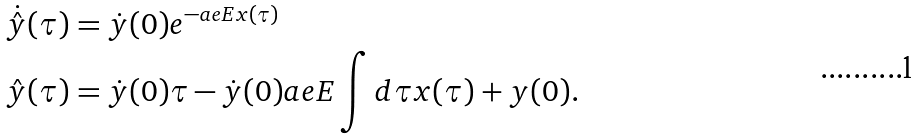Convert formula to latex. <formula><loc_0><loc_0><loc_500><loc_500>\dot { \hat { y } } ( \tau ) & = \dot { y } ( 0 ) e ^ { - a e E x ( \tau ) } \\ \hat { y } ( \tau ) & = \dot { y } ( 0 ) \tau - \dot { y } ( 0 ) a e E \int d \tau x ( \tau ) + y ( 0 ) .</formula> 